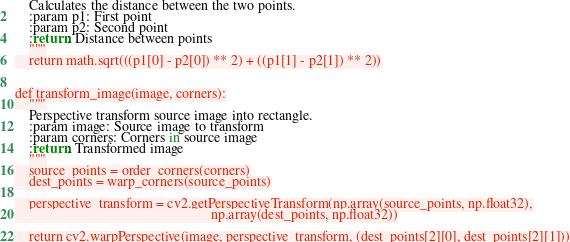Convert code to text. <code><loc_0><loc_0><loc_500><loc_500><_Python_>    Calculates the distance between the two points.
    :param p1: First point
    :param p2: Second point
    :return: Distance between points
    """
    return math.sqrt(((p1[0] - p2[0]) ** 2) + ((p1[1] - p2[1]) ** 2))


def transform_image(image, corners):
    """
    Perspective transform source image into rectangle.
    :param image: Source image to transform
    :param corners: Corners in source image
    :return: Transformed image
    """
    source_points = order_corners(corners)
    dest_points = warp_corners(source_points)

    perspective_transform = cv2.getPerspectiveTransform(np.array(source_points, np.float32),
                                                        np.array(dest_points, np.float32))

    return cv2.warpPerspective(image, perspective_transform, (dest_points[2][0], dest_points[2][1]))
</code> 